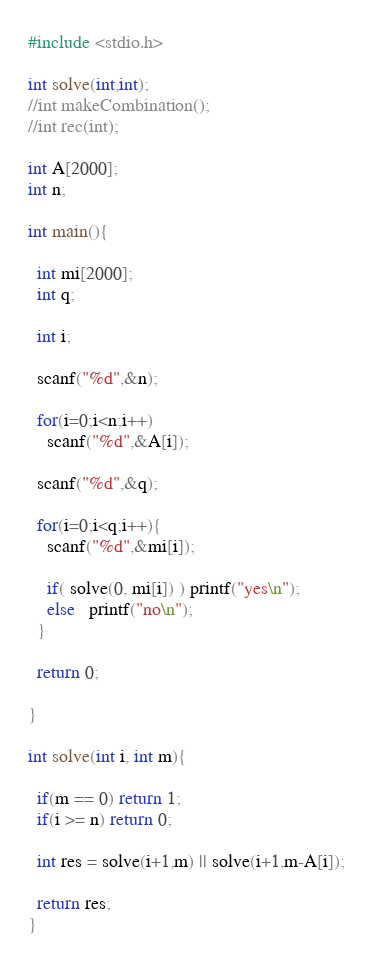<code> <loc_0><loc_0><loc_500><loc_500><_C_>#include <stdio.h>

int solve(int,int);
//int makeCombination();
//int rec(int);

int A[2000];  
int n;

int main(){

  int mi[2000];
  int q;
 
  int i;

  scanf("%d",&n);

  for(i=0;i<n;i++)
    scanf("%d",&A[i]);
  
  scanf("%d",&q);
  
  for(i=0;i<q;i++){
    scanf("%d",&mi[i]);
    
    if( solve(0, mi[i]) ) printf("yes\n");
    else   printf("no\n");
  }

  return 0;

}
	
int solve(int i, int m){

  if(m == 0) return 1;
  if(i >= n) return 0;

  int res = solve(i+1,m) || solve(i+1,m-A[i]);

  return res;
}</code> 